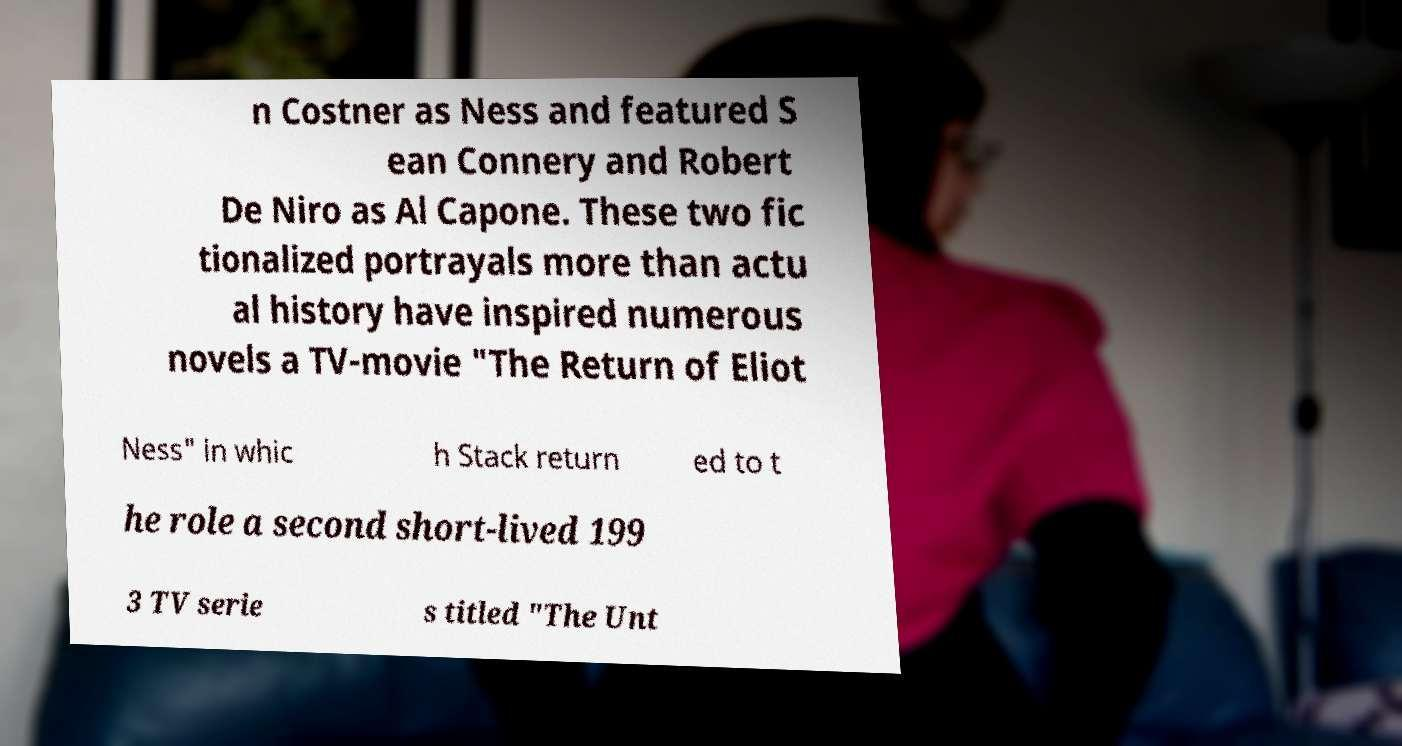For documentation purposes, I need the text within this image transcribed. Could you provide that? n Costner as Ness and featured S ean Connery and Robert De Niro as Al Capone. These two fic tionalized portrayals more than actu al history have inspired numerous novels a TV-movie "The Return of Eliot Ness" in whic h Stack return ed to t he role a second short-lived 199 3 TV serie s titled "The Unt 